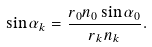<formula> <loc_0><loc_0><loc_500><loc_500>\sin { \alpha _ { k } } = \frac { r _ { 0 } n _ { 0 } \sin { \alpha _ { 0 } } } { r _ { k } n _ { k } } .</formula> 